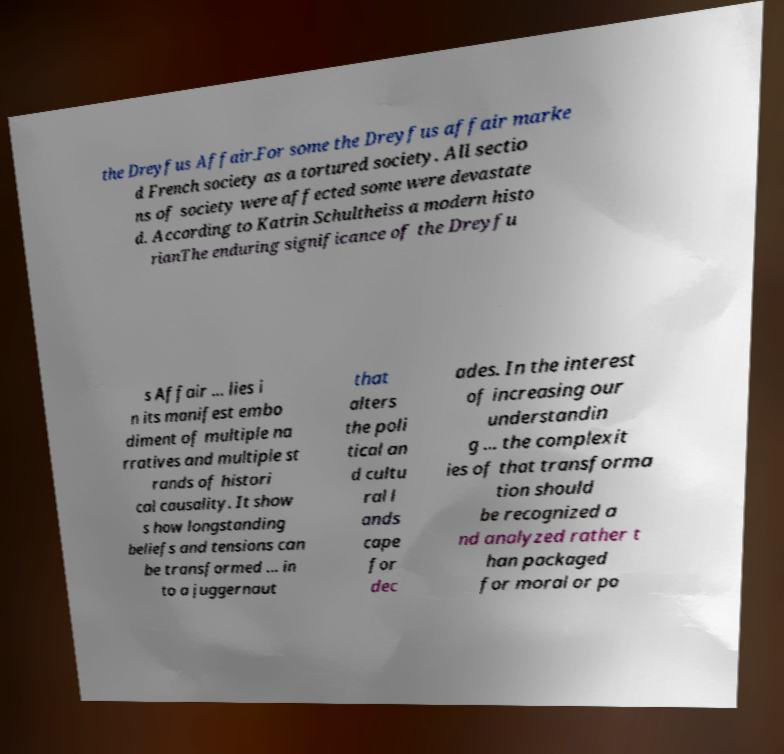Could you assist in decoding the text presented in this image and type it out clearly? the Dreyfus Affair.For some the Dreyfus affair marke d French society as a tortured society. All sectio ns of society were affected some were devastate d. According to Katrin Schultheiss a modern histo rianThe enduring significance of the Dreyfu s Affair ... lies i n its manifest embo diment of multiple na rratives and multiple st rands of histori cal causality. It show s how longstanding beliefs and tensions can be transformed ... in to a juggernaut that alters the poli tical an d cultu ral l ands cape for dec ades. In the interest of increasing our understandin g ... the complexit ies of that transforma tion should be recognized a nd analyzed rather t han packaged for moral or po 